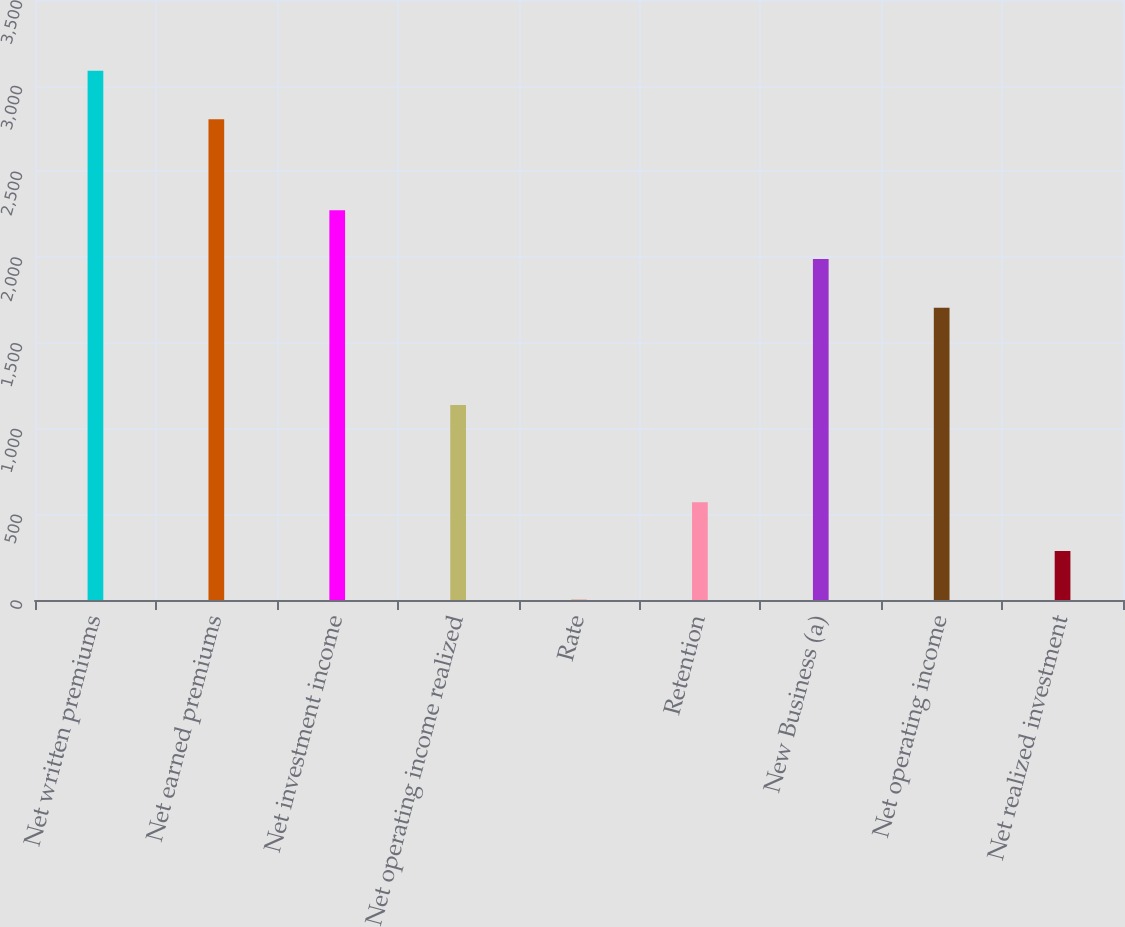Convert chart to OTSL. <chart><loc_0><loc_0><loc_500><loc_500><bar_chart><fcel>Net written premiums<fcel>Net earned premiums<fcel>Net investment income<fcel>Net operating income realized<fcel>Rate<fcel>Retention<fcel>New Business (a)<fcel>Net operating income<fcel>Net realized investment<nl><fcel>3087.9<fcel>2804<fcel>2273.2<fcel>1137.6<fcel>2<fcel>569.8<fcel>1989.3<fcel>1705.4<fcel>285.9<nl></chart> 